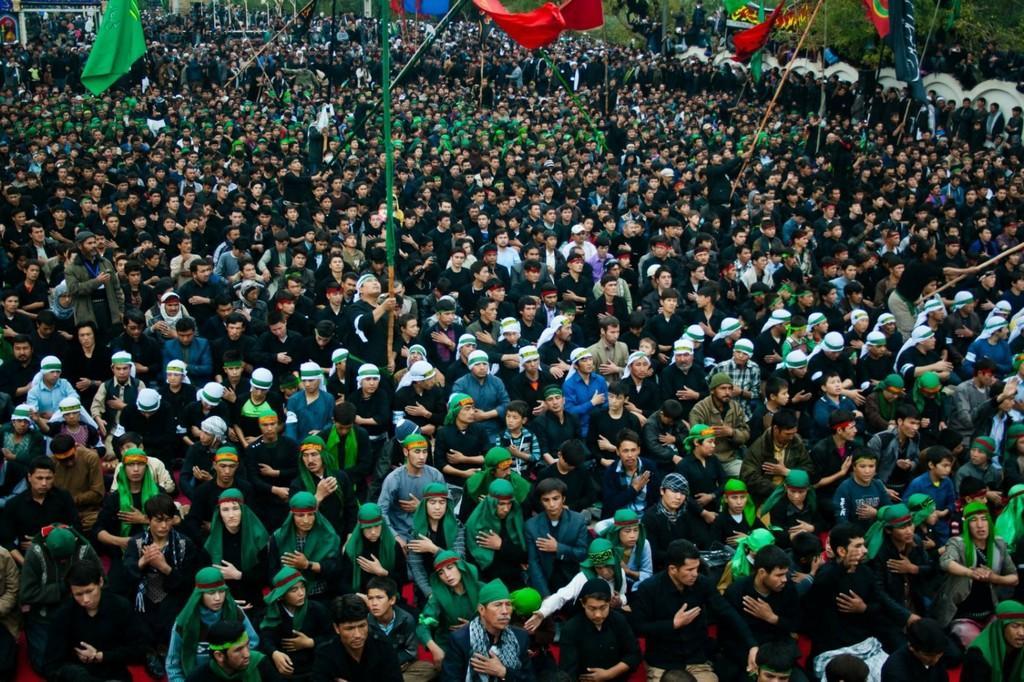Please provide a concise description of this image. In this image there are a group of people who are wearing headscarf, and there are some poles and flags. And in the background there are trees, buildings, poles and ropes. 